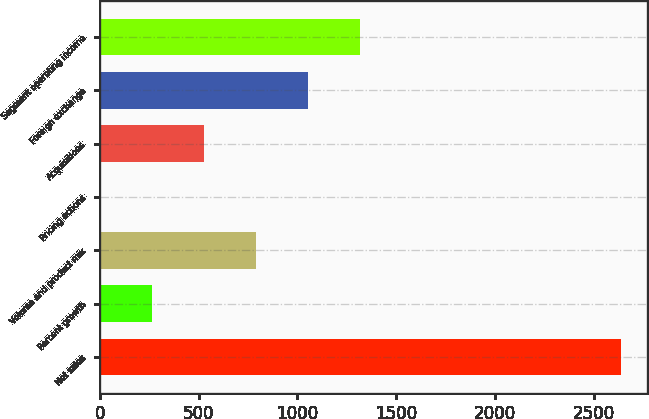Convert chart to OTSL. <chart><loc_0><loc_0><loc_500><loc_500><bar_chart><fcel>Net sales<fcel>Percent growth<fcel>Volume and product mix<fcel>Pricing actions<fcel>Acquisitions<fcel>Foreign exchange<fcel>Segment operating income<nl><fcel>2635.2<fcel>263.61<fcel>790.63<fcel>0.1<fcel>527.12<fcel>1054.14<fcel>1317.65<nl></chart> 